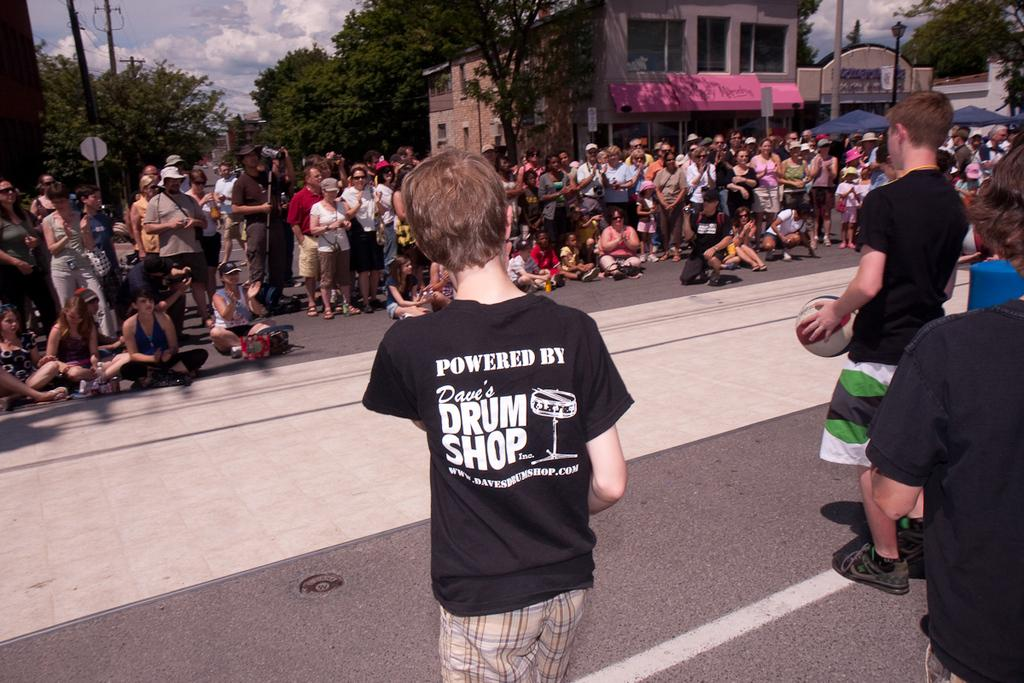What is happening on the roads in the image? There are many people on the roads in the image. What are some people doing on the roads? Some people are sitting on the road. What can be seen in the distance in the image? There are buildings visible in the background of the image. What type of natural elements are present in the background of the image? Trees are present in the background of the image. What type of stitch is being used to sew the hall in the image? There is no hall or stitching present in the image; it features people on the roads and buildings in the background. 